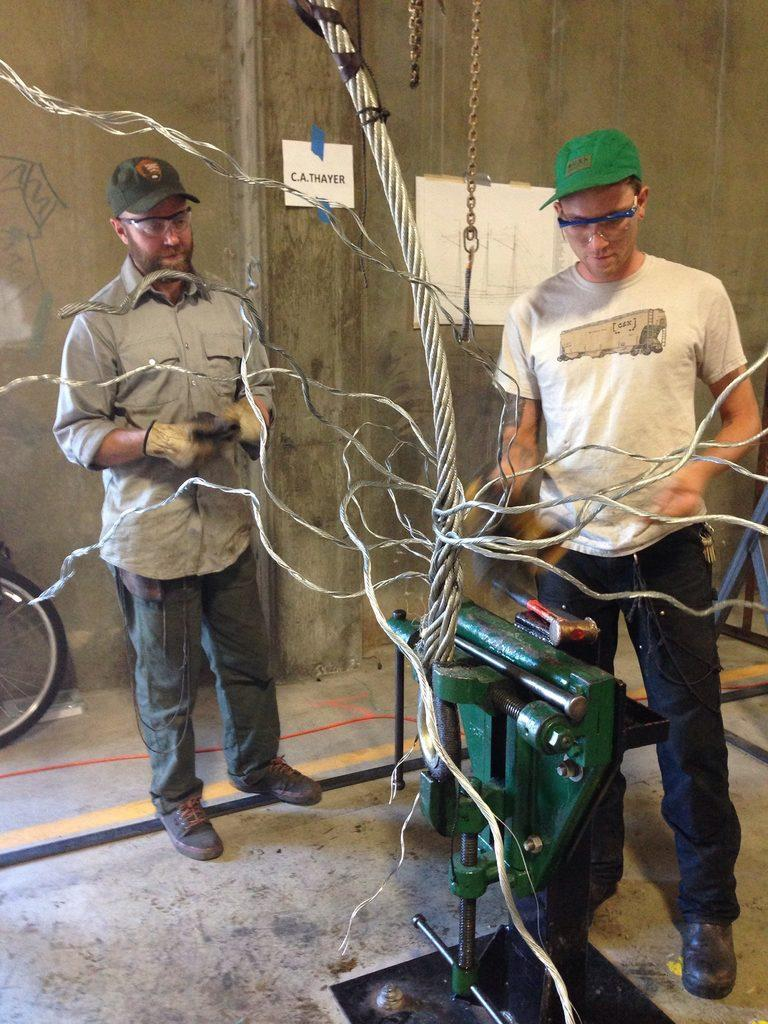How many people are in the image? There are two people in the image. What are the people doing in the image? The people are standing in front of a machine. How is the machine connected in the image? The machine is connected with cables. What is visible behind the people and the machine? There is a wall behind the people and the machine. What type of pump is being used to generate profit in the image? There is no pump or mention of profit in the image; it features two people standing in front of a machine connected with cables. Can you see any beetles in the image? There are no beetles present in the image. 